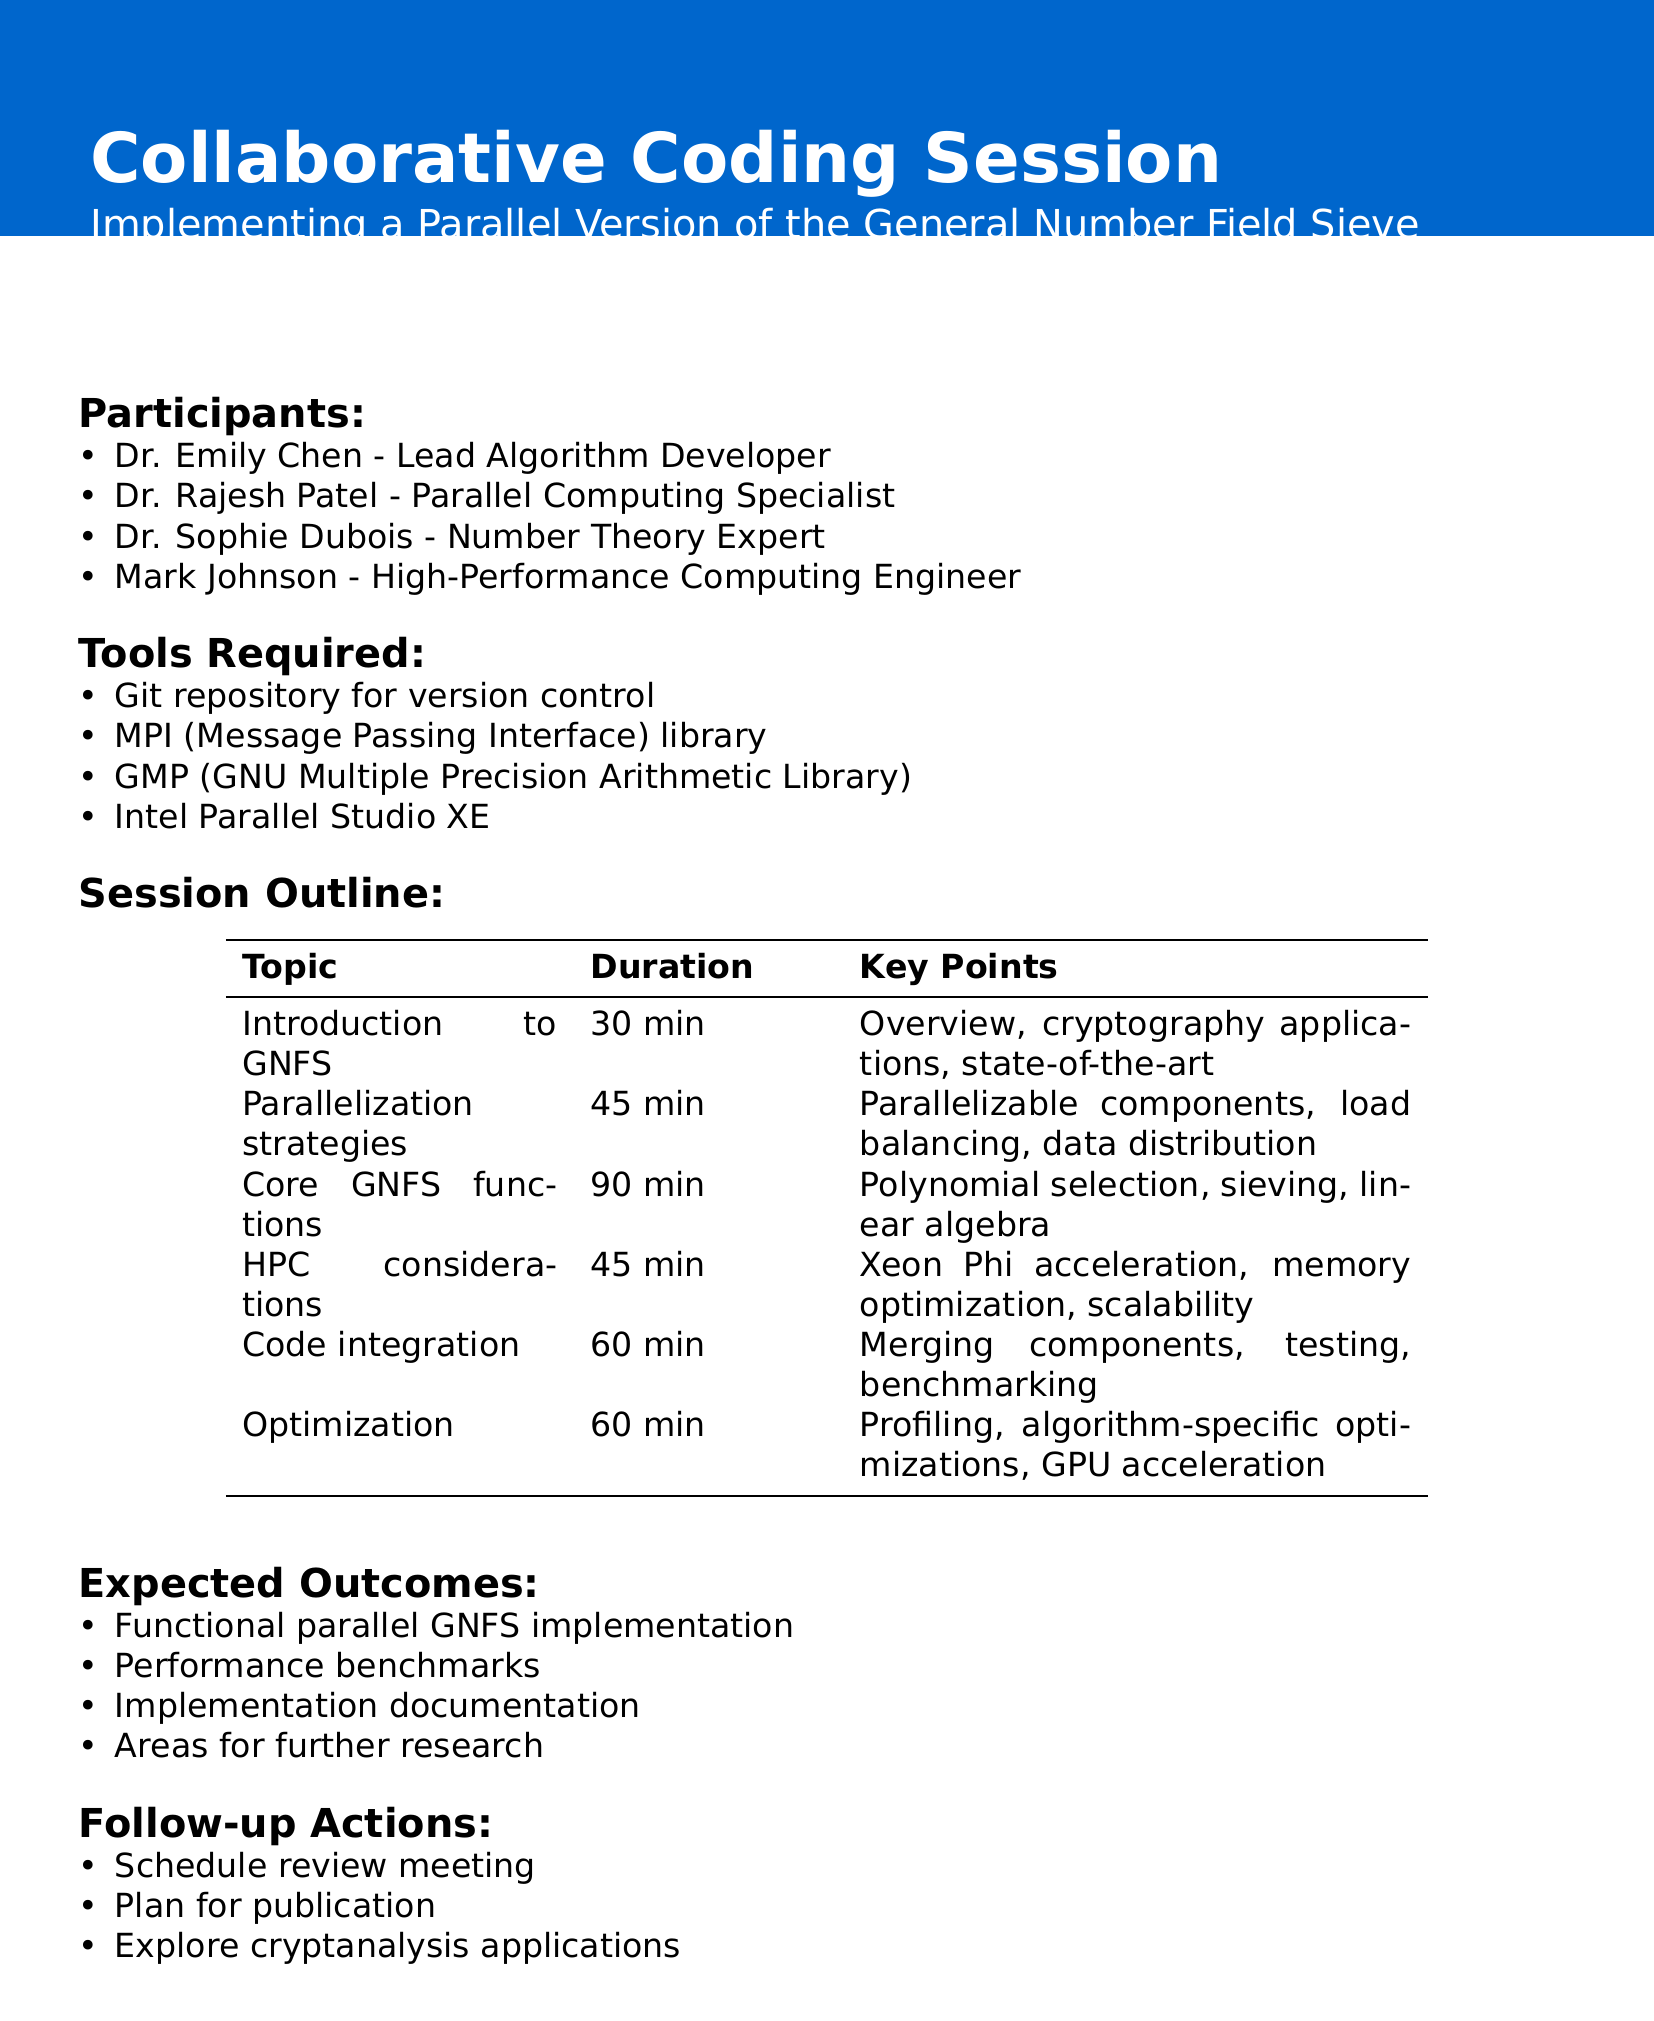what is the title of the session? The title of the session is explicitly mentioned at the beginning of the agenda.
Answer: Collaborative Coding Session: Implementing a Parallel Version of the General Number Field Sieve who is the speaker for the session on High-performance computing considerations? The document lists the speakers and their respective topics in the session outline.
Answer: Mark Johnson how long is the session on implementing core GNFS functions? The duration of the session is provided next to the topic in the session outline.
Answer: 90 minutes what is one of the required tools for the session? The document lists the tools required at the beginning of the agenda.
Answer: Git repository for version control what are the expected outcomes of the session? The document outlines the expected outcomes towards the end, summarizing the goals of the collaborative session.
Answer: A functional parallel implementation of GNFS identify one of the participants in the session. The participants are listed, and their titles are provided in the document.
Answer: Dr. Rajesh Patel - Parallel Computing Specialist which topic focuses on optimizing core GNFS functions? The topic is specifically mentioned in the session outline as dealing with core GNFS functions including optimizations.
Answer: Implementing core GNFS functions who is responsible for discussing parallelization strategies? The document specifies which speaker is covering each topic in the session outline.
Answer: Dr. Rajesh Patel what will be one follow-up action after the session? Follow-up actions are listed at the end of the document to outline what will occur post-session.
Answer: Schedule a review meeting to discuss the implementation results 